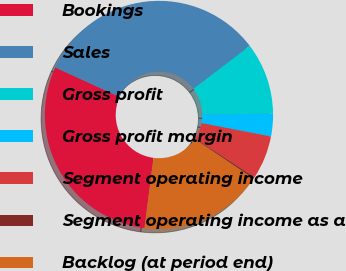Convert chart. <chart><loc_0><loc_0><loc_500><loc_500><pie_chart><fcel>Bookings<fcel>Sales<fcel>Gross profit<fcel>Gross profit margin<fcel>Segment operating income<fcel>Segment operating income as a<fcel>Backlog (at period end)<nl><fcel>29.81%<fcel>32.8%<fcel>10.19%<fcel>3.2%<fcel>6.2%<fcel>0.21%<fcel>17.59%<nl></chart> 